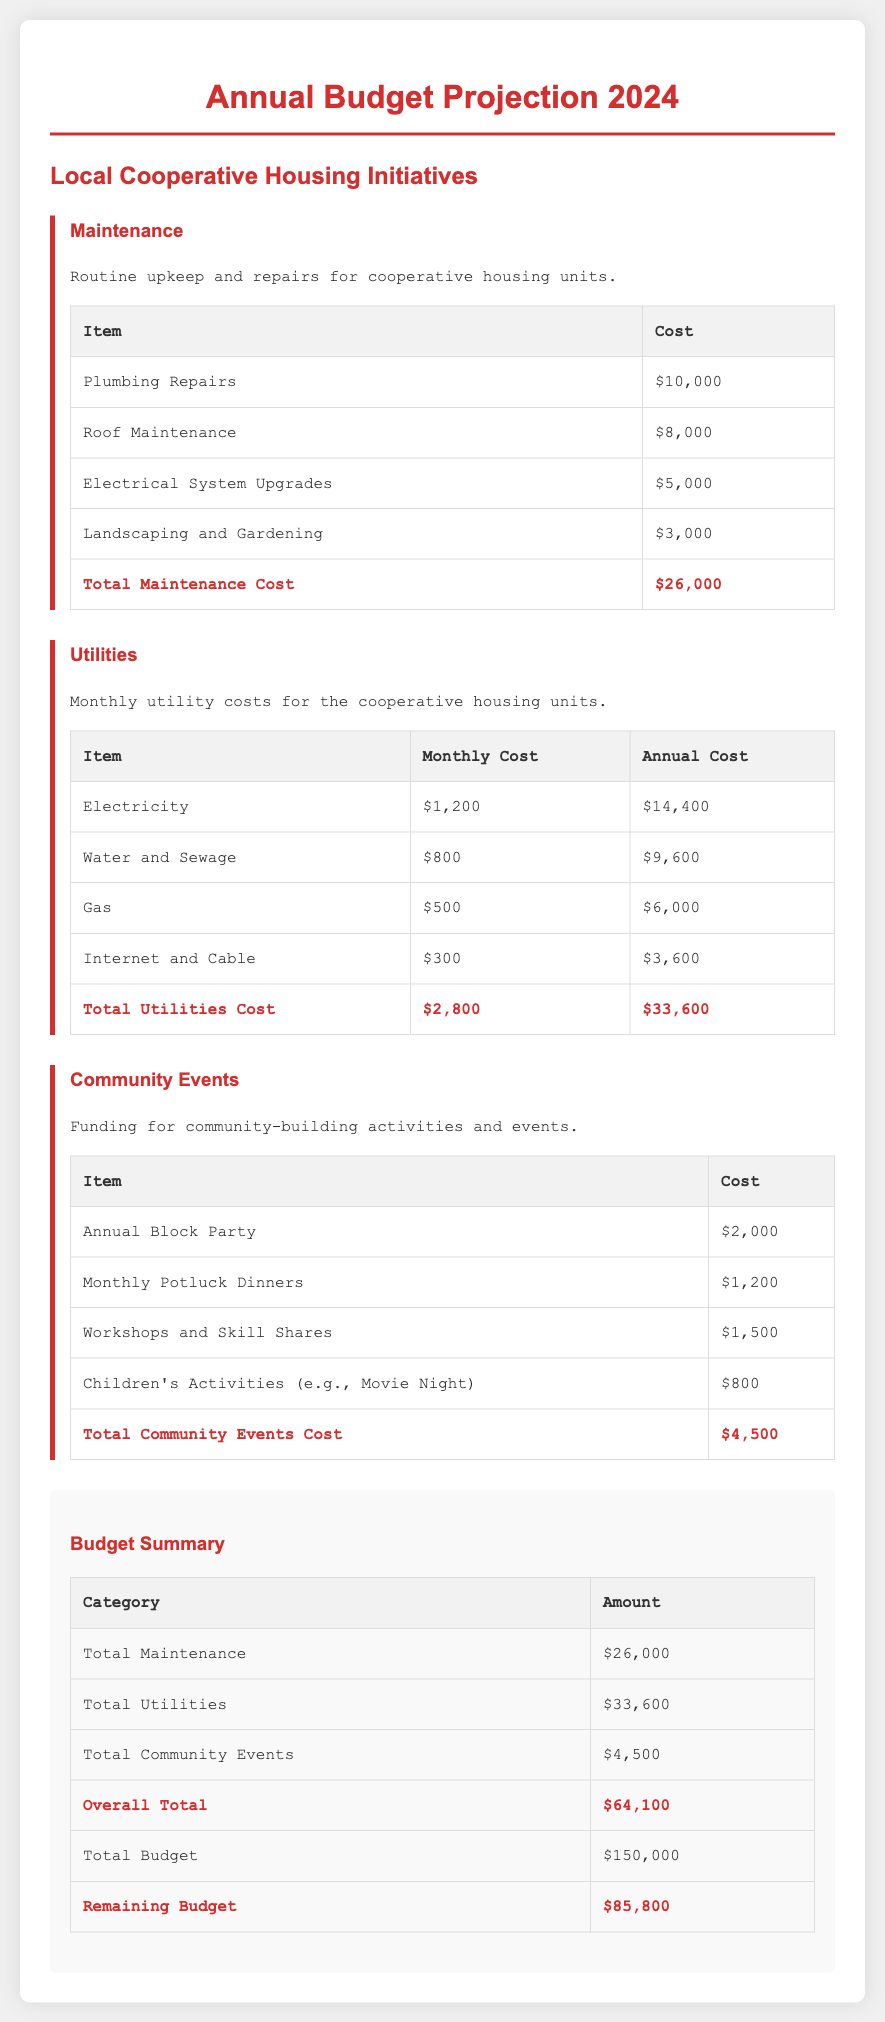What is the total maintenance cost? The total maintenance cost is provided in the maintenance section of the document, which sums to $26,000.
Answer: $26,000 What is the annual cost for electricity? The annual cost for electricity is mentioned in the utilities section, which is $14,400.
Answer: $14,400 What amount is allocated for workshops and skill shares? The amount allocated for workshops and skill shares is specified in the community events section as $1,500.
Answer: $1,500 What is the overall total budget? The overall total budget is presented in the budget summary, which is $64,100.
Answer: $64,100 How much is the remaining budget? The remaining budget is indicated in the budget summary as $85,800.
Answer: $85,800 What is the total cost for water and sewage utilities? The total cost for water and sewage is listed in the utilities table, amounting to $9,600.
Answer: $9,600 What is the funding for the annual block party? The funding for the annual block party is described in the community events section as $2,000.
Answer: $2,000 What is the total utilities cost? The total utilities cost is calculated in the utilities section, which totals to $33,600.
Answer: $33,600 